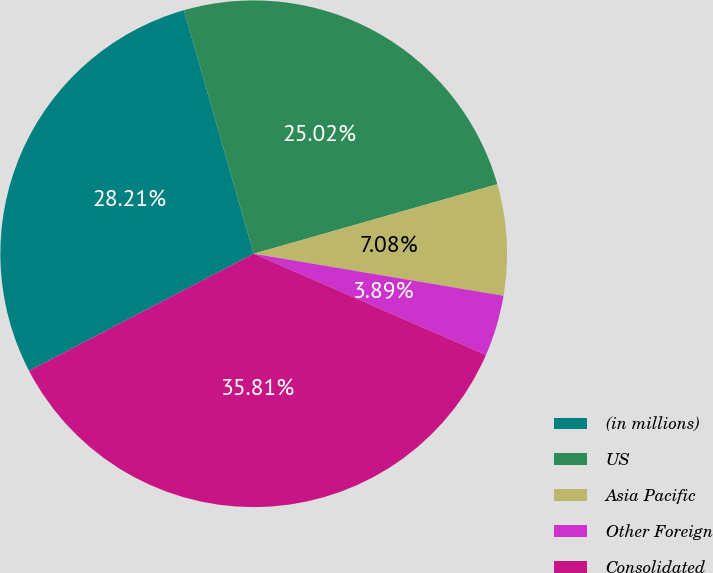<chart> <loc_0><loc_0><loc_500><loc_500><pie_chart><fcel>(in millions)<fcel>US<fcel>Asia Pacific<fcel>Other Foreign<fcel>Consolidated<nl><fcel>28.21%<fcel>25.02%<fcel>7.08%<fcel>3.89%<fcel>35.81%<nl></chart> 